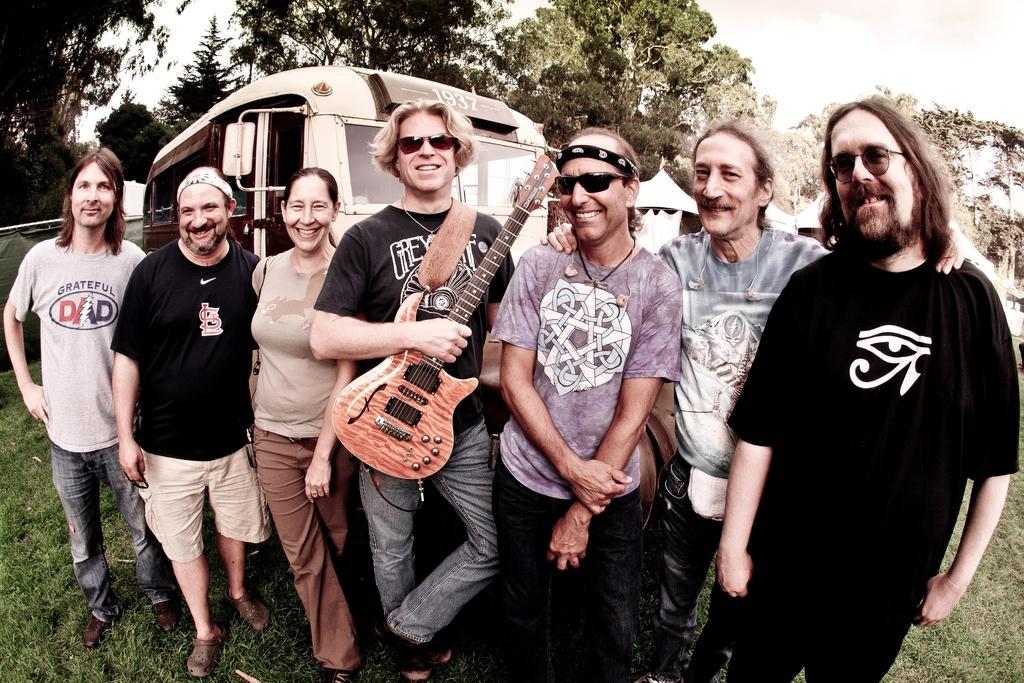Describe this image in one or two sentences. A group of people are posing at a camera. 